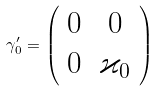<formula> <loc_0><loc_0><loc_500><loc_500>\gamma _ { 0 } ^ { \prime } = \left ( \begin{array} { c c } 0 & 0 \\ 0 & \varkappa _ { 0 } \end{array} \right )</formula> 